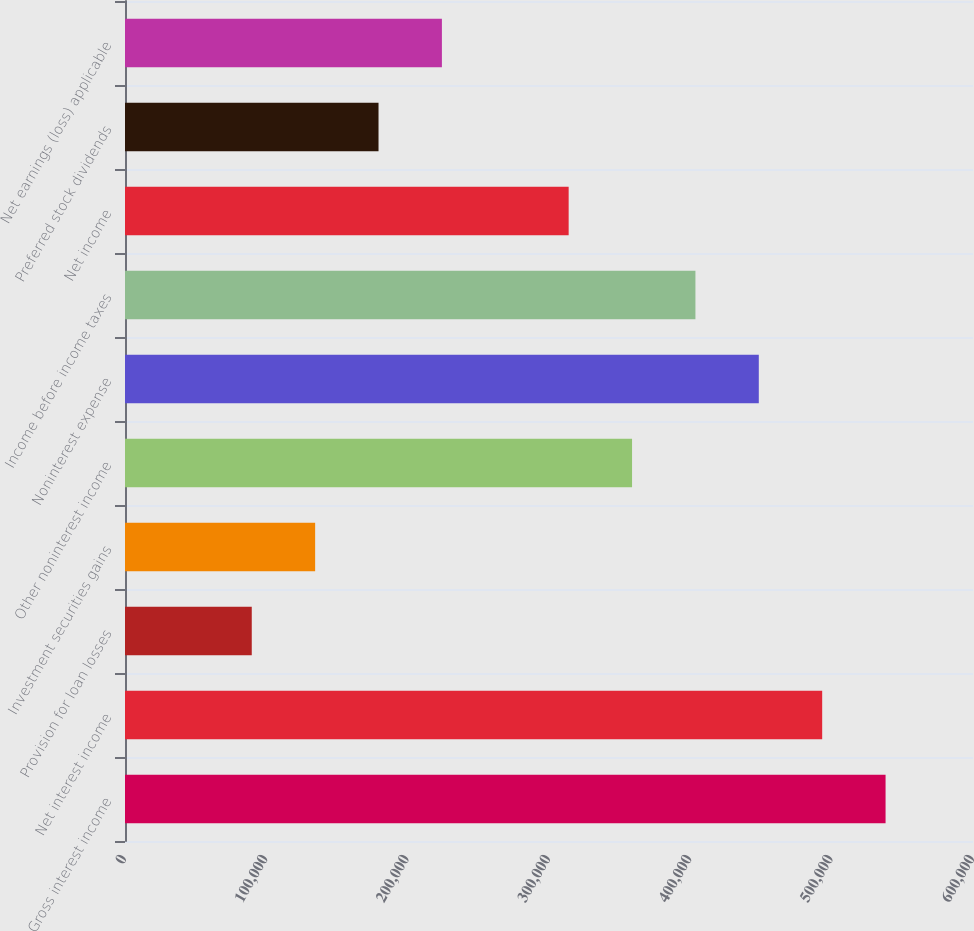Convert chart. <chart><loc_0><loc_0><loc_500><loc_500><bar_chart><fcel>Gross interest income<fcel>Net interest income<fcel>Provision for loan losses<fcel>Investment securities gains<fcel>Other noninterest income<fcel>Noninterest expense<fcel>Income before income taxes<fcel>Net income<fcel>Preferred stock dividends<fcel>Net earnings (loss) applicable<nl><fcel>538135<fcel>493291<fcel>89689.5<fcel>134534<fcel>358757<fcel>448446<fcel>403601<fcel>313912<fcel>179379<fcel>224223<nl></chart> 